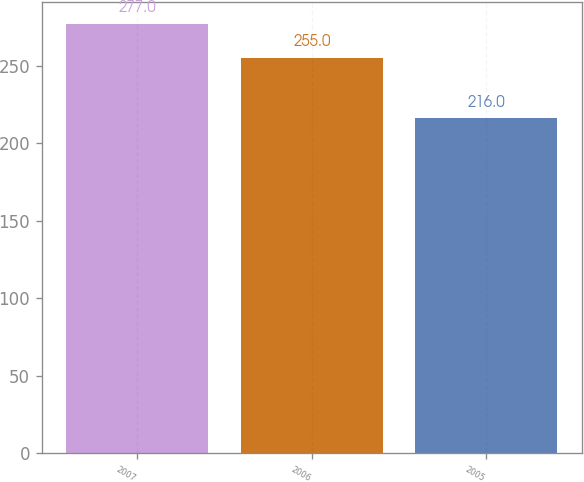Convert chart. <chart><loc_0><loc_0><loc_500><loc_500><bar_chart><fcel>2007<fcel>2006<fcel>2005<nl><fcel>277<fcel>255<fcel>216<nl></chart> 